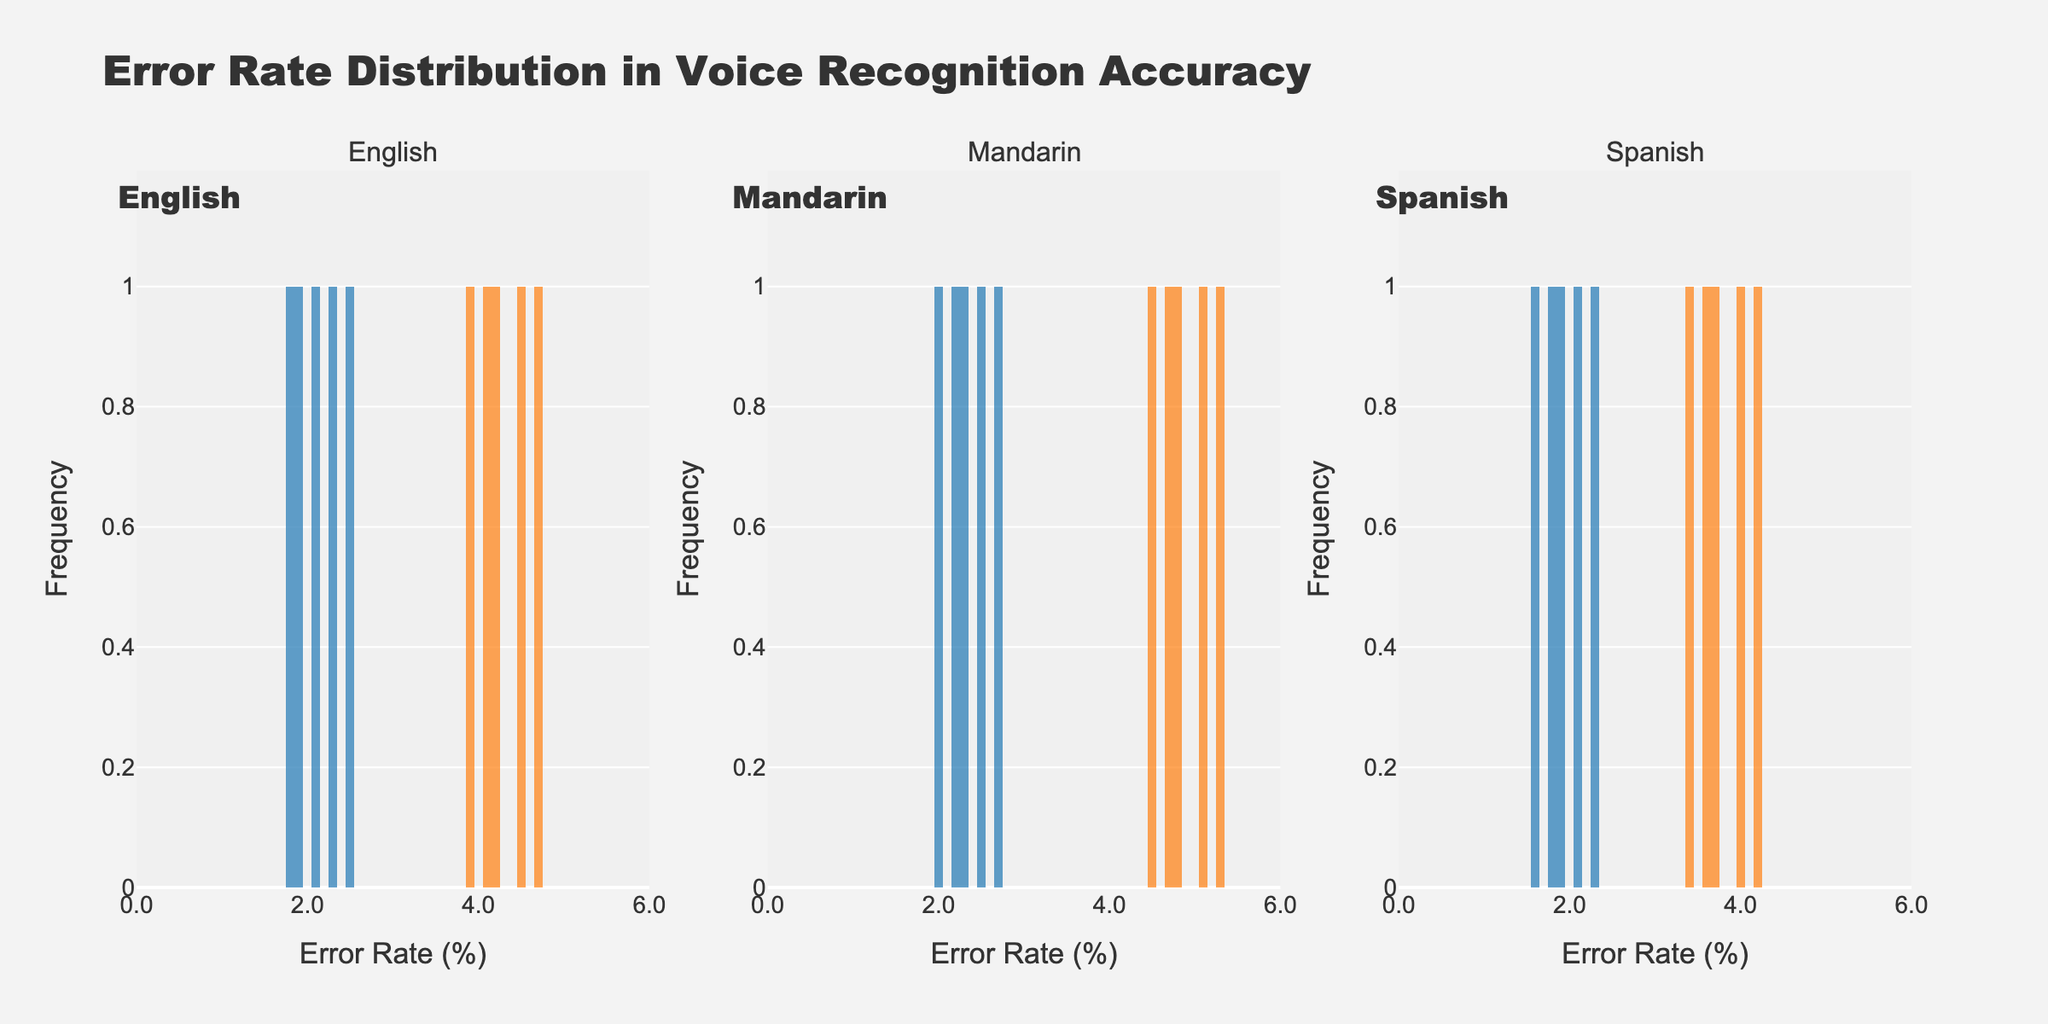What's the title of the figure? The title is usually displayed at the top of the figure. In this case, it reads "Error Rate Distribution in Voice Recognition Accuracy".
Answer: Error Rate Distribution in Voice Recognition Accuracy What's the x-axis label in each subplot? The x-axis label is shown below the x-axis and is the same for all subplots. Here, it is "Error Rate (%)".
Answer: Error Rate (%) How many languages are compared in the figure? The figure contains three subplots, each representing a different language. Therefore, three languages are compared.
Answer: 3 Which speaker type generally has higher error rates in voice recognition? In each subplot, the histogram for 'Non-Native' speakers is shifted to the right compared to 'Native' speakers. This indicates higher error rates.
Answer: Non-Native What is the range of error rates for native speakers in the English language? The 'Native' histogram for the English subplot stretches from 1.8 to about 2.5.
Answer: 1.8 to 2.5 Which language shows the highest error rates for non-native speakers? By observing the rightmost heights of the histograms in each subplot, Mandarin 'Non-Native' speakers show the highest error rate (up to 5.3).
Answer: Mandarin Compare the error rate distributions for native speakers of Mandarin and Spanish. The Mandarin 'Native' speakers have error rates ranging between 2.0 and 2.7, while Spanish 'Native' speakers range between 1.6 and 2.3. Both distributions are relatively low, but the Mandarin distribution is slightly broader.
Answer: Mandarin's error rates range from 2.0 to 2.7, and Spanish from 1.6 to 2.3 Which language has the smallest gap between native and non-native error rates? The difference between the highest non-native and native error rates is smallest in the Spanish subplot (4.2 - 1.6 = 2.6), compared with English (4.7 - 1.8 = 2.9) and Mandarin (5.3 - 2.0 = 3.3).
Answer: Spanish How many bins are used in the histograms? By observing the histogram bars, the figure appears to have divided the data into 10 bins for each histogram.
Answer: 10 Are there any overlapping error rate distributions, and if so, which ones? Overlapping can be seen in all subplots where the histograms of native and non-native speakers overlap in the error rate range. Specifically, the overlapping regions are from 2.1 to 2.5 (English), 2.2 to 2.7 (Mandarin), and 1.8 to 2.3 (Spanish).
Answer: Yes, English (2.1-2.5), Mandarin (2.2-2.7), Spanish (1.8-2.3) 